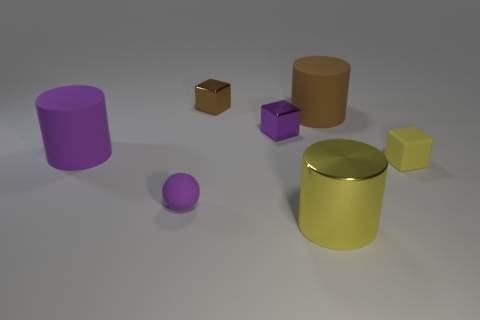Add 3 small purple matte blocks. How many objects exist? 10 Subtract all balls. How many objects are left? 6 Add 2 big yellow metal objects. How many big yellow metal objects are left? 3 Add 7 big yellow shiny cubes. How many big yellow shiny cubes exist? 7 Subtract 0 green balls. How many objects are left? 7 Subtract all big cyan rubber objects. Subtract all small brown metal cubes. How many objects are left? 6 